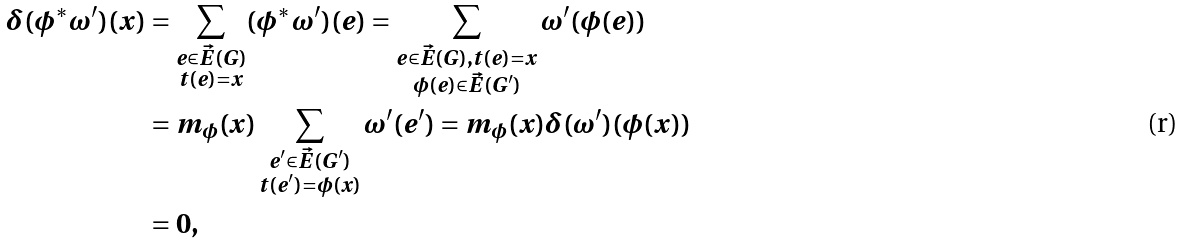<formula> <loc_0><loc_0><loc_500><loc_500>\delta ( \phi ^ { * } \omega ^ { \prime } ) ( x ) & = \sum _ { \substack { e \in \vec { E } ( G ) \\ t ( e ) = x } } ( \phi ^ { * } \omega ^ { \prime } ) ( e ) = \sum _ { \substack { e \in \vec { E } ( G ) , t ( e ) = x \\ \phi ( e ) \in \vec { E } ( G ^ { \prime } ) } } \omega ^ { \prime } ( \phi ( e ) ) \\ & = m _ { \phi } ( x ) \sum _ { \substack { e ^ { \prime } \in \vec { E } ( G ^ { \prime } ) \\ t ( e ^ { \prime } ) = \phi ( x ) } } \omega ^ { \prime } ( e ^ { \prime } ) = m _ { \phi } ( x ) \delta ( \omega ^ { \prime } ) ( \phi ( x ) ) \\ & = 0 ,</formula> 